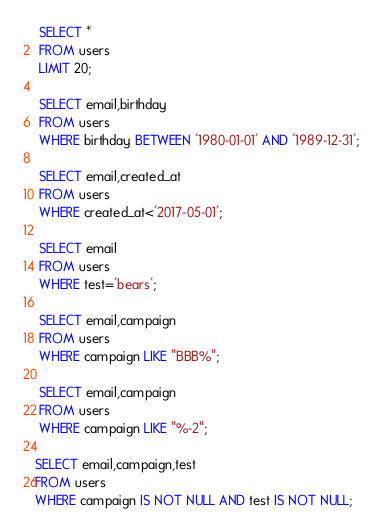Convert code to text. <code><loc_0><loc_0><loc_500><loc_500><_SQL_> SELECT *
 FROM users
 LIMIT 20;

 SELECT email,birthday
 FROM users
 WHERE birthday BETWEEN '1980-01-01' AND '1989-12-31';

 SELECT email,created_at
 FROM users
 WHERE created_at<'2017-05-01';

 SELECT email
 FROM users
 WHERE test='bears';

 SELECT email,campaign
 FROM users
 WHERE campaign LIKE "BBB%";

 SELECT email,campaign
 FROM users
 WHERE campaign LIKE "%-2";

SELECT email,campaign,test
FROM users
WHERE campaign IS NOT NULL AND test IS NOT NULL;</code> 